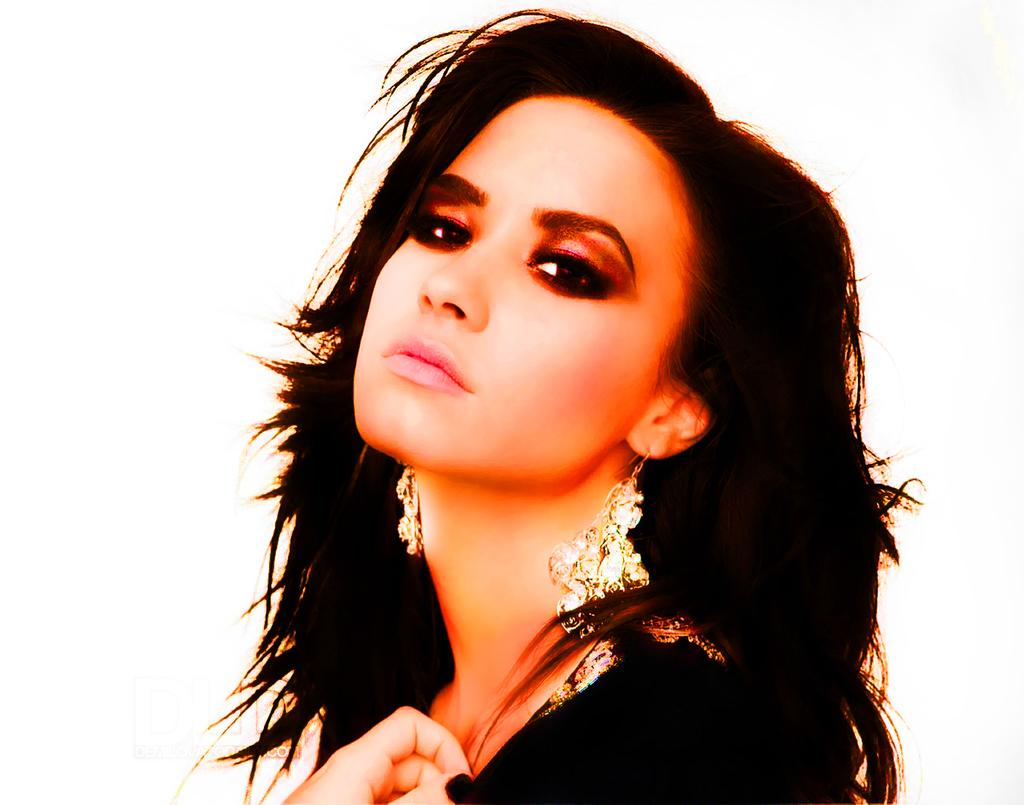What is the main subject of the image? There is a lady in the image. What can be seen in the background of the image? The background of the image is white. What type of trains can be seen in the image? There are no trains present in the image. 